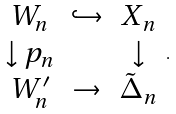<formula> <loc_0><loc_0><loc_500><loc_500>\begin{array} { c c c } W _ { n } & \hookrightarrow & X _ { n } \\ \downarrow p _ { n } & & \downarrow \\ W _ { n } ^ { \prime } & \rightarrow & \tilde { \Delta } _ { n } \end{array} .</formula> 